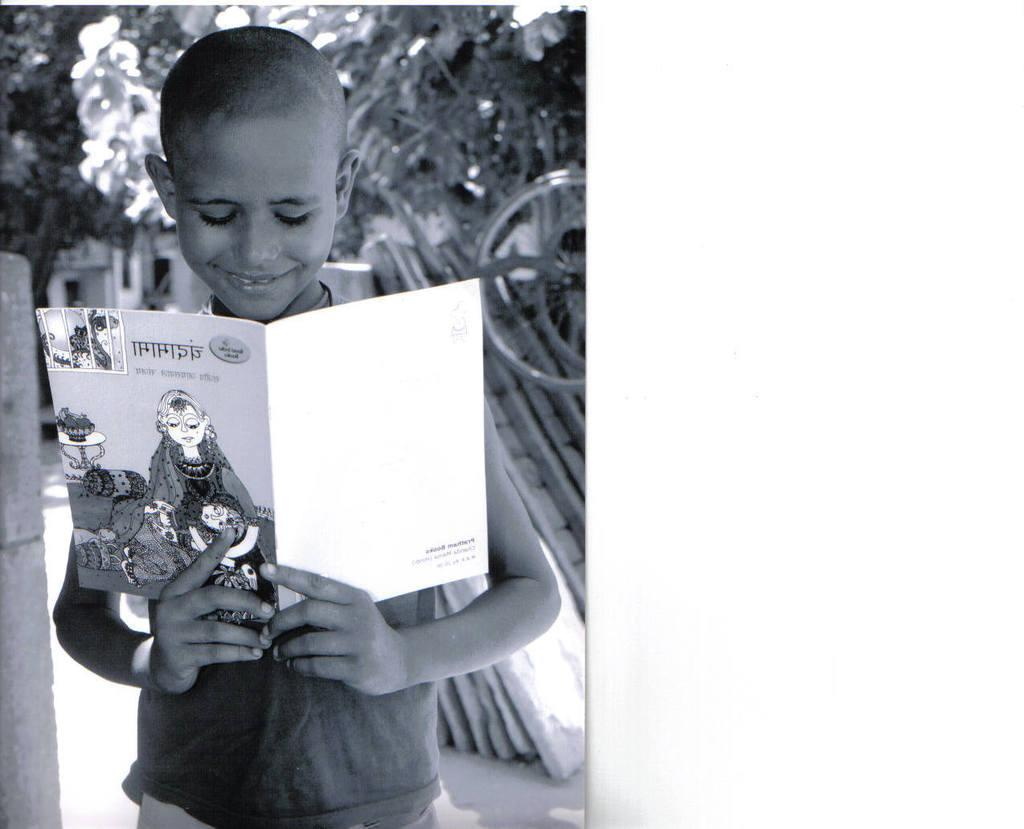What is the color scheme of the image? The image is black and white. Who is the main subject in the image? There is a boy in the image. Where is the boy positioned in the image? The boy is standing in the foreground. What is the boy holding in the image? The boy is holding a book. How is the background of the boy depicted in the image? The background of the boy is blurred. How many books are visible in the image? There is only one book visible in the image, as the boy is holding a single book. What is the limit of the angle at which the boy can read the book in the image? There is no information provided about the angle at which the boy is reading the book, nor is there any indication of a limit to the angle. 